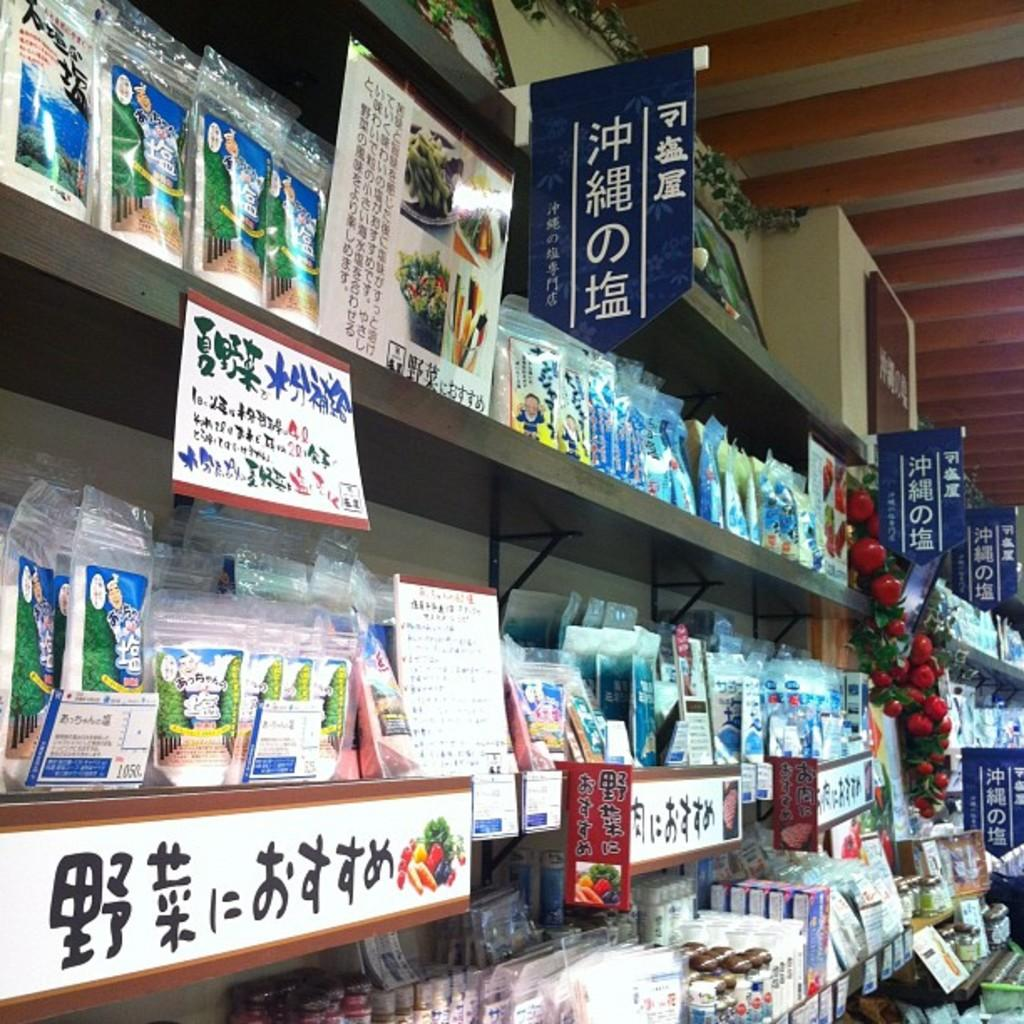<image>
Create a compact narrative representing the image presented. The second row of items, far left has a card with the numbers 1050 in the lower right corner. 